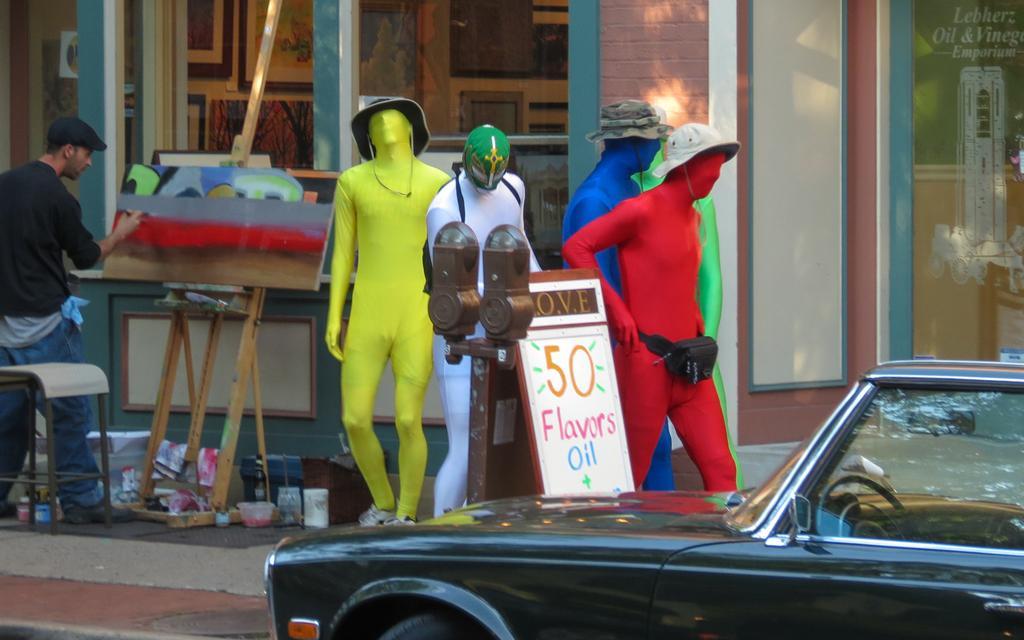How would you summarize this image in a sentence or two? In this image on the right side, I can see a vehicle. On the left side I can see a person painting on the board. I can also see it looks like the statues. In the background, I can see the photo frames on the wall. 